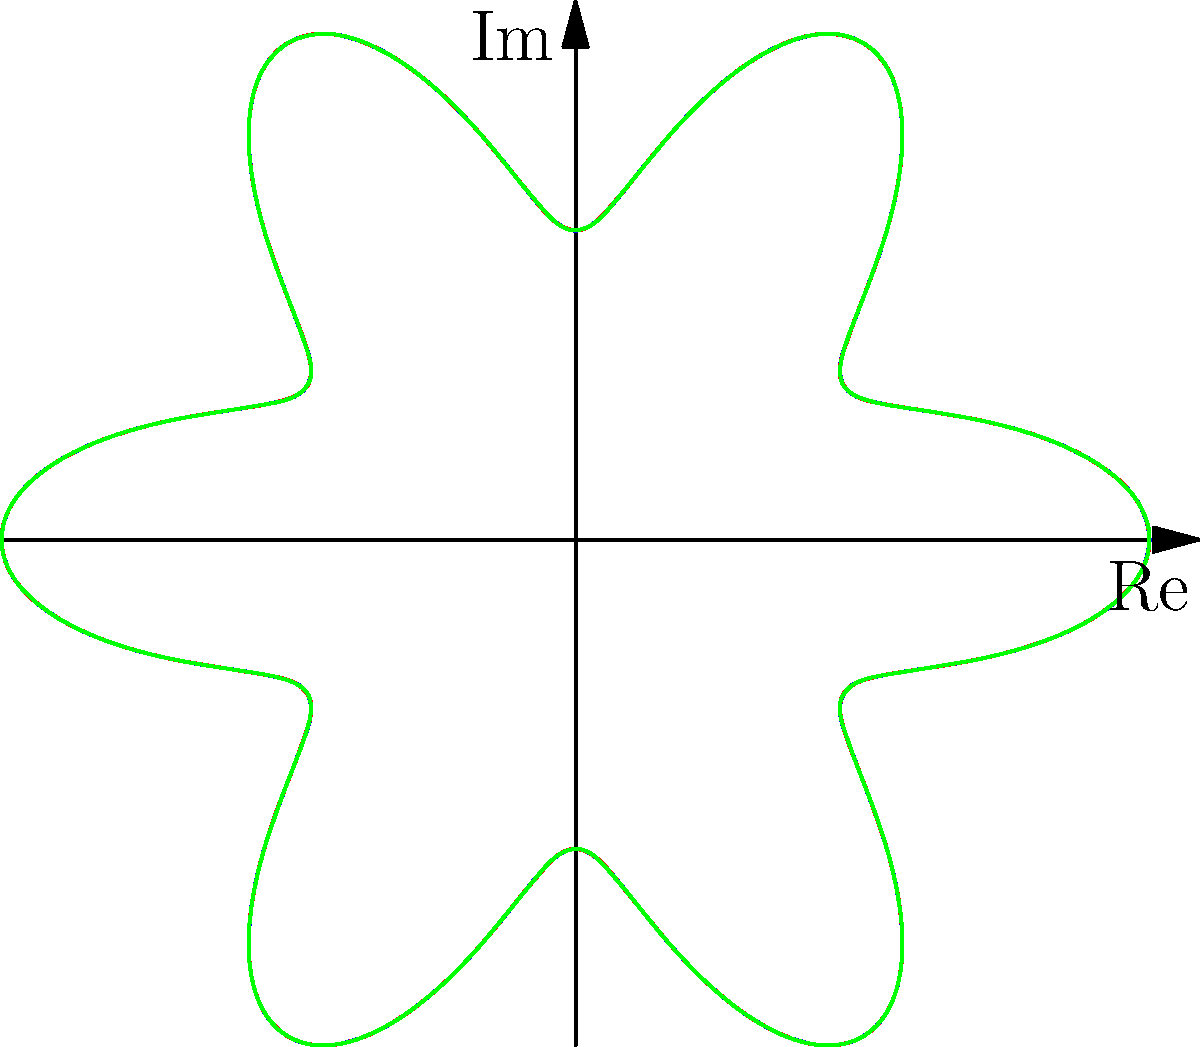In the polar coordinate representation of a mandala design shown above, how many total petals are formed by the overlapping of the three rotated versions of the curve $r = 1 + 0.3\cos(6\theta)$? To determine the number of petals in this mandala design, let's follow these steps:

1. Analyze the base curve: $r = 1 + 0.3\cos(6\theta)$
   - The function $\cos(6\theta)$ completes 6 full cycles in $2\pi$ radians.
   - This means the base curve (blue) has 6 petals.

2. Consider the rotations:
   - The base curve is rotated by 60° (red) and 120° (green).
   - 60° rotation: $\frac{60°}{360°} \times 6 = 1$ petal offset
   - 120° rotation: $\frac{120°}{360°} \times 6 = 2$ petals offset

3. Overlay effect:
   - The three curves (blue, red, green) are symmetrically overlaid.
   - Each curve contributes 6 petals.
   - The rotations ensure that the petals from different curves do not perfectly overlap.

4. Count the total petals:
   - In a full $360°$ rotation, we see all petals from all three curves.
   - Total petals = 6 (blue) + 6 (red) + 6 (green) = 18 petals

Therefore, the mandala design formed by the overlapping of the three rotated versions of the curve has a total of 18 petals.
Answer: 18 petals 